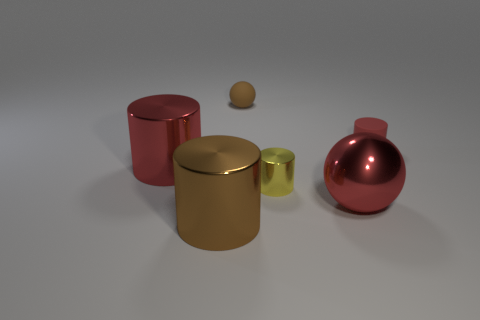Add 3 green matte cylinders. How many objects exist? 9 Subtract all balls. How many objects are left? 4 Subtract all large brown cylinders. Subtract all tiny yellow cylinders. How many objects are left? 4 Add 5 cylinders. How many cylinders are left? 9 Add 4 small red cylinders. How many small red cylinders exist? 5 Subtract 0 red blocks. How many objects are left? 6 